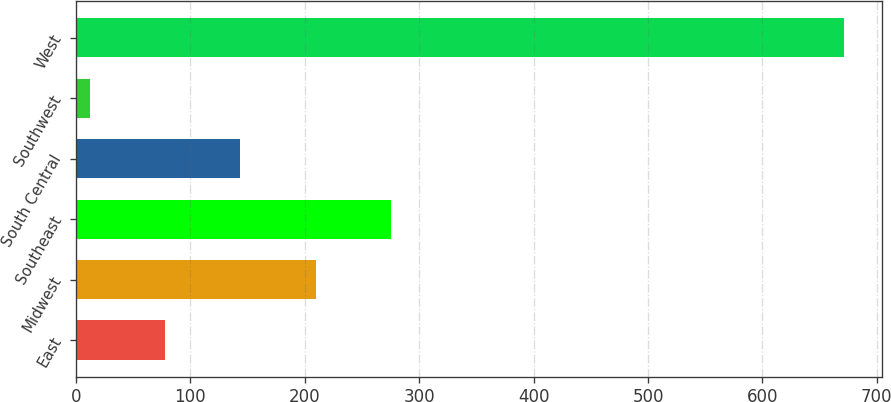Convert chart. <chart><loc_0><loc_0><loc_500><loc_500><bar_chart><fcel>East<fcel>Midwest<fcel>Southeast<fcel>South Central<fcel>Southwest<fcel>West<nl><fcel>77.81<fcel>209.63<fcel>275.54<fcel>143.72<fcel>11.9<fcel>671<nl></chart> 